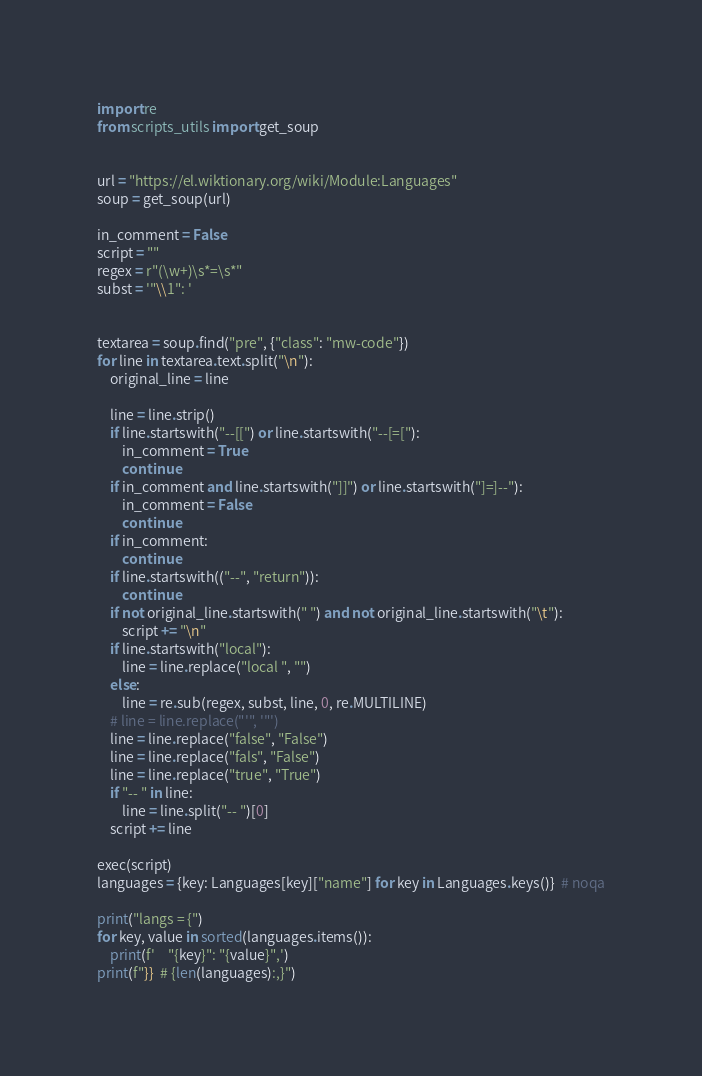<code> <loc_0><loc_0><loc_500><loc_500><_Python_>import re
from scripts_utils import get_soup


url = "https://el.wiktionary.org/wiki/Module:Languages"
soup = get_soup(url)

in_comment = False
script = ""
regex = r"(\w+)\s*=\s*"
subst = '"\\1": '


textarea = soup.find("pre", {"class": "mw-code"})
for line in textarea.text.split("\n"):
    original_line = line

    line = line.strip()
    if line.startswith("--[[") or line.startswith("--[=["):
        in_comment = True
        continue
    if in_comment and line.startswith("]]") or line.startswith("]=]--"):
        in_comment = False
        continue
    if in_comment:
        continue
    if line.startswith(("--", "return")):
        continue
    if not original_line.startswith(" ") and not original_line.startswith("\t"):
        script += "\n"
    if line.startswith("local"):
        line = line.replace("local ", "")
    else:
        line = re.sub(regex, subst, line, 0, re.MULTILINE)
    # line = line.replace("'", '"')
    line = line.replace("false", "False")
    line = line.replace("fals", "False")
    line = line.replace("true", "True")
    if "-- " in line:
        line = line.split("-- ")[0]
    script += line

exec(script)
languages = {key: Languages[key]["name"] for key in Languages.keys()}  # noqa

print("langs = {")
for key, value in sorted(languages.items()):
    print(f'    "{key}": "{value}",')
print(f"}}  # {len(languages):,}")
</code> 